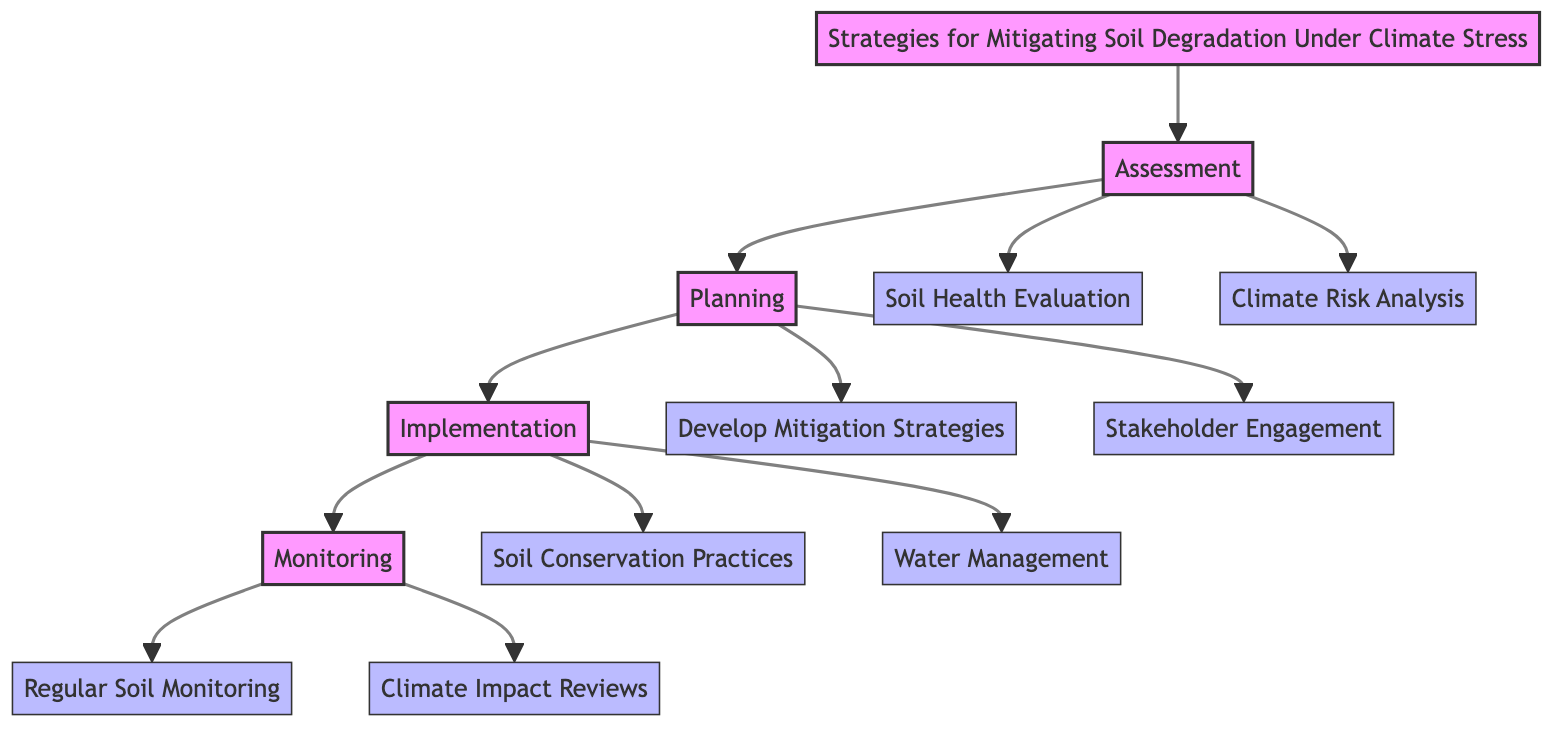What is the first phase in the pathway? The pathway begins with the "Assessment" phase, which is clearly labeled as the first step in the progression of the diagram.
Answer: Assessment How many steps are there in the Implementation phase? The Implementation phase contains two steps: "Soil Conservation Practices" and "Water Management," which are both listed under that phase in the diagram.
Answer: 2 What is the last step of the pathway? The last step identified in the diagram is "Climate Impact Reviews," which is under the Monitoring phase, the final phase in the sequence.
Answer: Climate Impact Reviews What connects the Assessment to the Planning phase? The connection between the Assessment phase and the Planning phase is indicated by an arrow, representing the progression from one phase to the next in the clinical pathway.
Answer: Arrow Which real-world entity is associated with Regular Soil Monitoring? The "ARS Soil Health Monitoring" is specifically designated as the real-world entity related to the "Regular Soil Monitoring" step as noted in the diagram.
Answer: ARS Soil Health Monitoring What are the two steps in the Planning phase? The Planning phase includes "Develop Mitigation Strategies" and "Stakeholder Engagement," which are explicitly listed as the two steps of that phase.
Answer: Develop Mitigation Strategies, Stakeholder Engagement How many total phases are there in the Clinical Pathway? There are a total of four phases in the Clinical Pathway: Assessment, Planning, Implementation, and Monitoring, as listed sequentially in the diagram.
Answer: 4 What type of practices are suggested in the Implementation phase? The "Soil Conservation Practices" and "Water Management" are the types of practices suggested within the Implementation phase to mitigate soil degradation.
Answer: Soil Conservation Practices, Water Management 